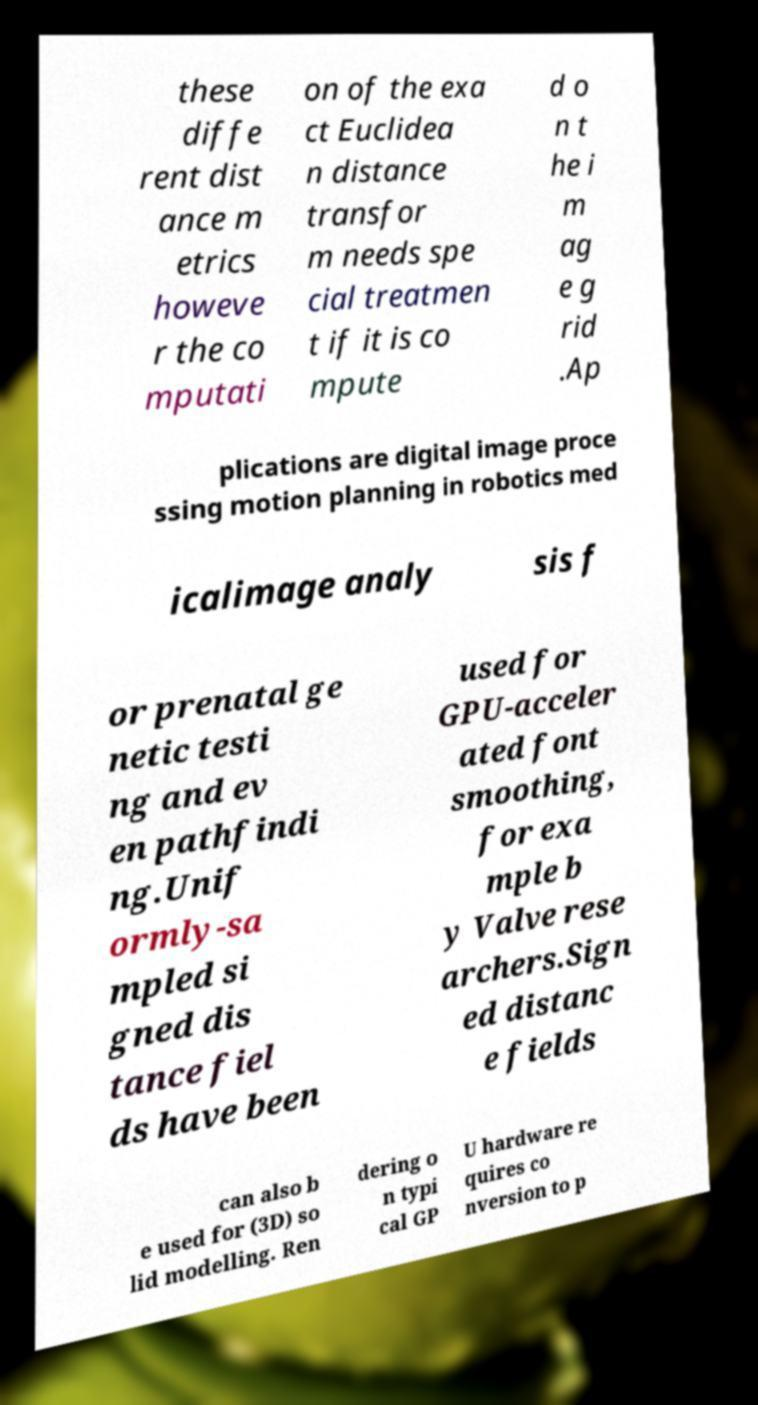I need the written content from this picture converted into text. Can you do that? these diffe rent dist ance m etrics howeve r the co mputati on of the exa ct Euclidea n distance transfor m needs spe cial treatmen t if it is co mpute d o n t he i m ag e g rid .Ap plications are digital image proce ssing motion planning in robotics med icalimage analy sis f or prenatal ge netic testi ng and ev en pathfindi ng.Unif ormly-sa mpled si gned dis tance fiel ds have been used for GPU-acceler ated font smoothing, for exa mple b y Valve rese archers.Sign ed distanc e fields can also b e used for (3D) so lid modelling. Ren dering o n typi cal GP U hardware re quires co nversion to p 